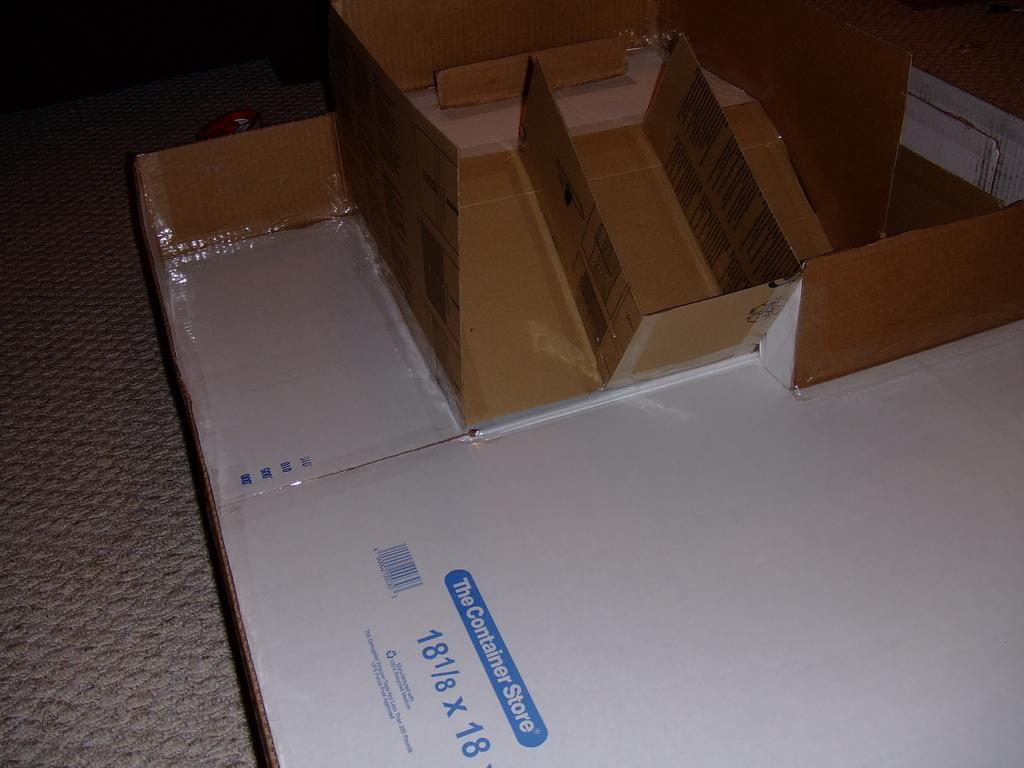<image>
Render a clear and concise summary of the photo. A folded box from the Container Store lays on the floor. 